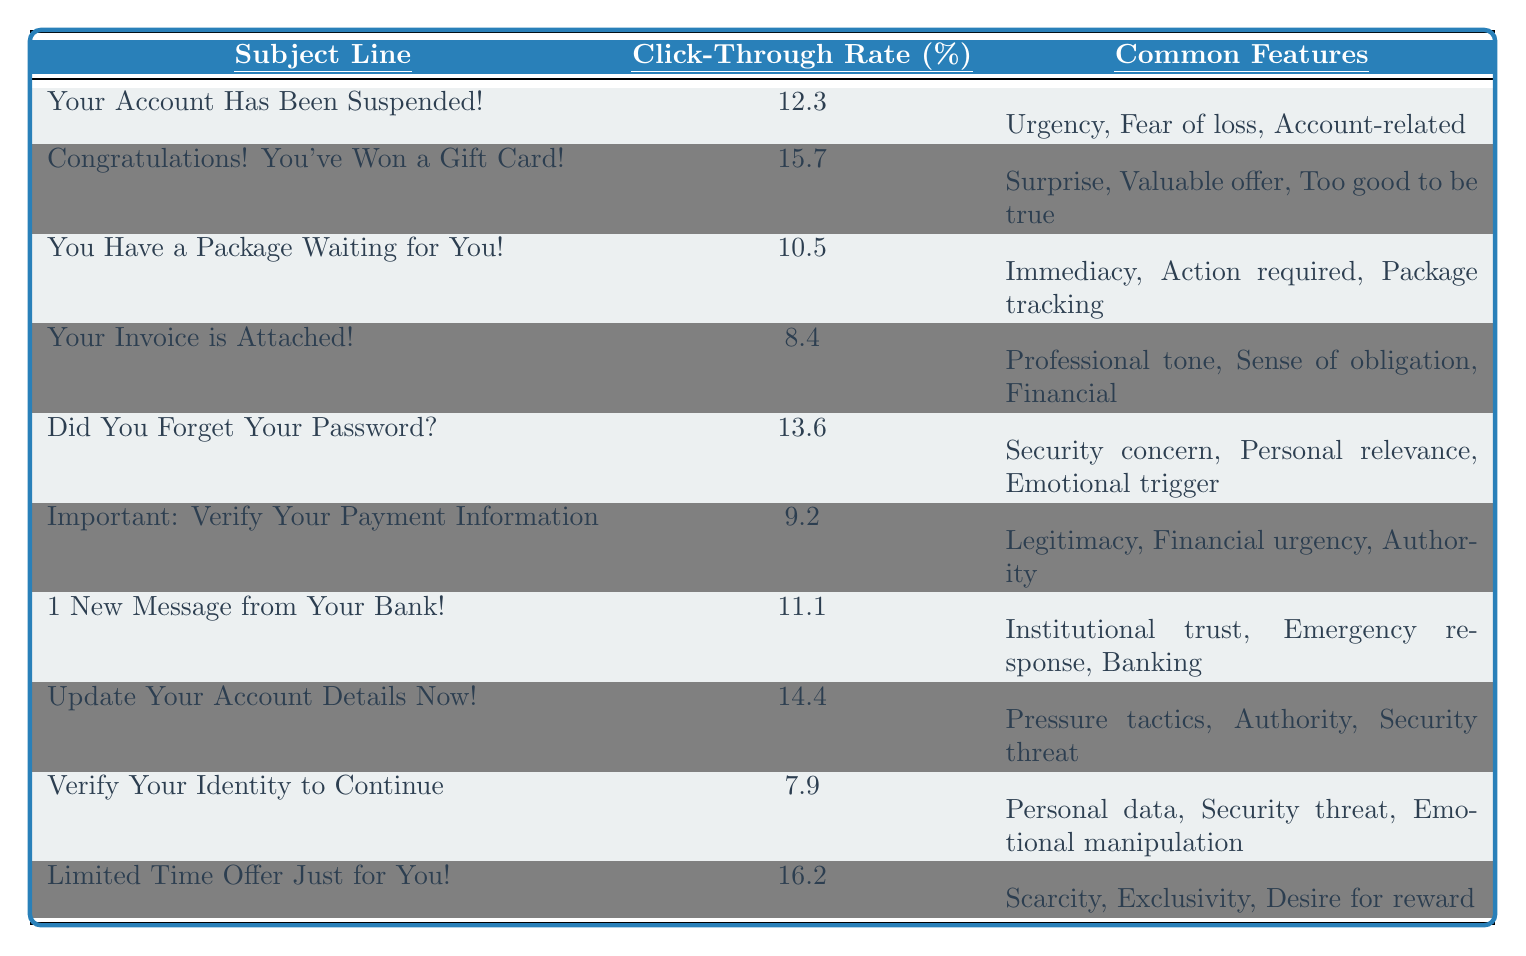What is the subject line with the highest click-through rate? Reviewing the table, the subject line "Limited Time Offer Just for You!" has the highest click-through rate of 16.2%.
Answer: Limited Time Offer Just for You! What are the common features of the subject line "Your Account Has Been Suspended!"? The table lists the common features for this subject line as Urgency, Fear of loss, and Account-related.
Answer: Urgency, Fear of loss, Account-related What is the average click-through rate of all the subject lines? To calculate the average, sum all the click-through rates: (12.3 + 15.7 + 10.5 + 8.4 + 13.6 + 9.2 + 11.1 + 14.4 + 7.9 + 16.2) = 129.3. There are 10 subject lines, so the average is 129.3 / 10 = 12.93.
Answer: 12.93 Is the click-through rate for "Verify Your Identity to Continue" above 10%? The click-through rate for this subject line is 7.9%, which is below 10%. Therefore, the answer is no.
Answer: No What is the difference between the click-through rates of "Congratulations! You've Won a Gift Card!" and "Your Invoice is Attached!"? The click-through rate for "Congratulations! You've Won a Gift Card!" is 15.7%, while for "Your Invoice is Attached!" it is 8.4%. The difference is 15.7 - 8.4 = 7.3%.
Answer: 7.3 Which subject line has a focus on emotional manipulation and what is its click-through rate? The subject line "Verify Your Identity to Continue" focuses on emotional manipulation, and its click-through rate is 7.9%.
Answer: Verify Your Identity to Continue; 7.9 Are more subject lines associated with urgency or with legitimacy? Examining the table, 5 subject lines include urgency traits: "Your Account Has Been Suspended!", "You Have a Package Waiting for You!", "Update Your Account Details Now!", "Limited Time Offer Just for You!", while only 2 link to legitimacy: "Important: Verify Your Payment Information" and "Your Invoice is Attached!". Therefore, urgency is more common.
Answer: Urgency What is the combined click-through rate of subject lines that include a sense of urgency? The subject lines with urgency are "Your Account Has Been Suspended!" (12.3), "You Have a Package Waiting for You!" (10.5), and "Update Your Account Details Now!" (14.4). The combined click-through rate is 12.3 + 10.5 + 14.4 = 37.2%.
Answer: 37.2 What percentage of the subject lines show a sense of financial urgency? The subject lines indicating financial urgency are "Your Invoice is Attached!" (8.4%) and "Important: Verify Your Payment Information" (9.2%). Only 2 out of 10 subject lines qualify, which is (2/10) * 100% = 20%.
Answer: 20 Which subject line has the lowest click-through rate and what are its common features? The subject line with the lowest click-through rate is "Verify Your Identity to Continue!" at 7.9%. Its common features are Personal data, Security threat, and Emotional manipulation.
Answer: Verify Your Identity to Continue!; Personal data, Security threat, Emotional manipulation 